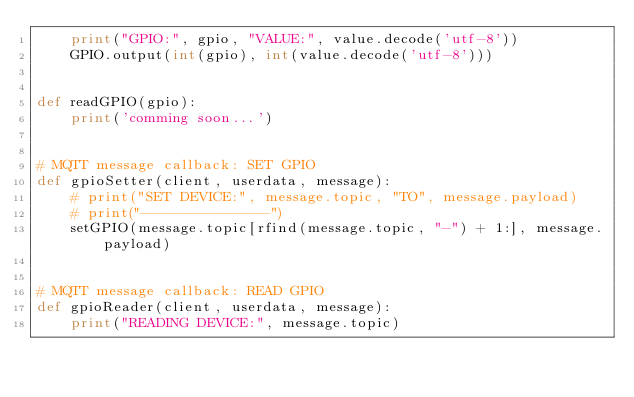Convert code to text. <code><loc_0><loc_0><loc_500><loc_500><_Python_>    print("GPIO:", gpio, "VALUE:", value.decode('utf-8'))
    GPIO.output(int(gpio), int(value.decode('utf-8')))


def readGPIO(gpio):
    print('comming soon...')


# MQTT message callback: SET GPIO
def gpioSetter(client, userdata, message):
    # print("SET DEVICE:", message.topic, "TO", message.payload)
    # print("--------------")
    setGPIO(message.topic[rfind(message.topic, "-") + 1:], message.payload)


# MQTT message callback: READ GPIO
def gpioReader(client, userdata, message):
    print("READING DEVICE:", message.topic)</code> 